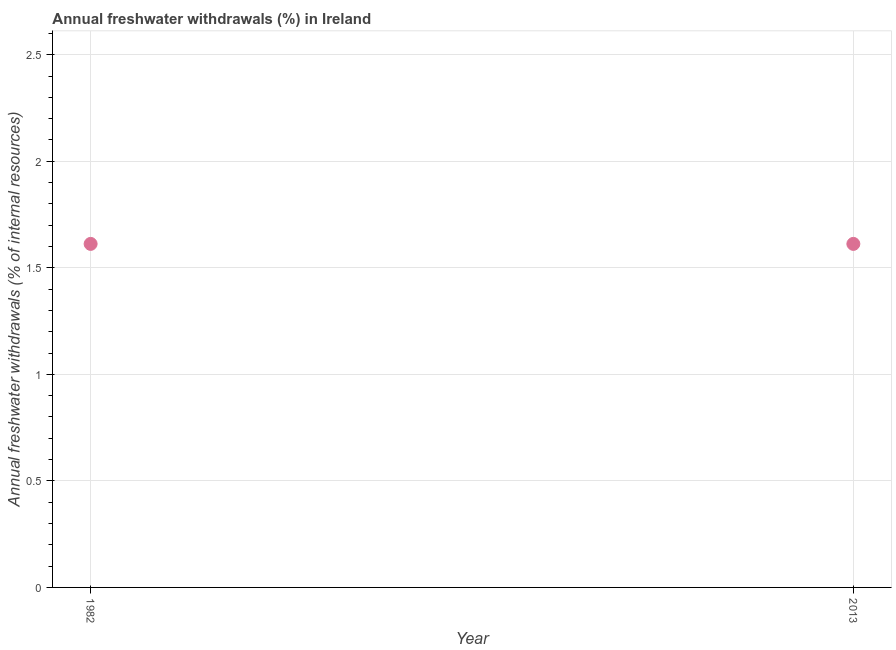What is the annual freshwater withdrawals in 2013?
Provide a succinct answer. 1.61. Across all years, what is the maximum annual freshwater withdrawals?
Offer a very short reply. 1.61. Across all years, what is the minimum annual freshwater withdrawals?
Offer a very short reply. 1.61. In which year was the annual freshwater withdrawals minimum?
Your response must be concise. 1982. What is the sum of the annual freshwater withdrawals?
Your response must be concise. 3.22. What is the difference between the annual freshwater withdrawals in 1982 and 2013?
Offer a very short reply. 0. What is the average annual freshwater withdrawals per year?
Your answer should be compact. 1.61. What is the median annual freshwater withdrawals?
Offer a terse response. 1.61. Do a majority of the years between 1982 and 2013 (inclusive) have annual freshwater withdrawals greater than 0.6 %?
Offer a very short reply. Yes. Does the annual freshwater withdrawals monotonically increase over the years?
Keep it short and to the point. No. How many years are there in the graph?
Provide a short and direct response. 2. What is the difference between two consecutive major ticks on the Y-axis?
Provide a short and direct response. 0.5. Are the values on the major ticks of Y-axis written in scientific E-notation?
Keep it short and to the point. No. What is the title of the graph?
Your answer should be very brief. Annual freshwater withdrawals (%) in Ireland. What is the label or title of the X-axis?
Offer a terse response. Year. What is the label or title of the Y-axis?
Ensure brevity in your answer.  Annual freshwater withdrawals (% of internal resources). What is the Annual freshwater withdrawals (% of internal resources) in 1982?
Your response must be concise. 1.61. What is the Annual freshwater withdrawals (% of internal resources) in 2013?
Keep it short and to the point. 1.61. 